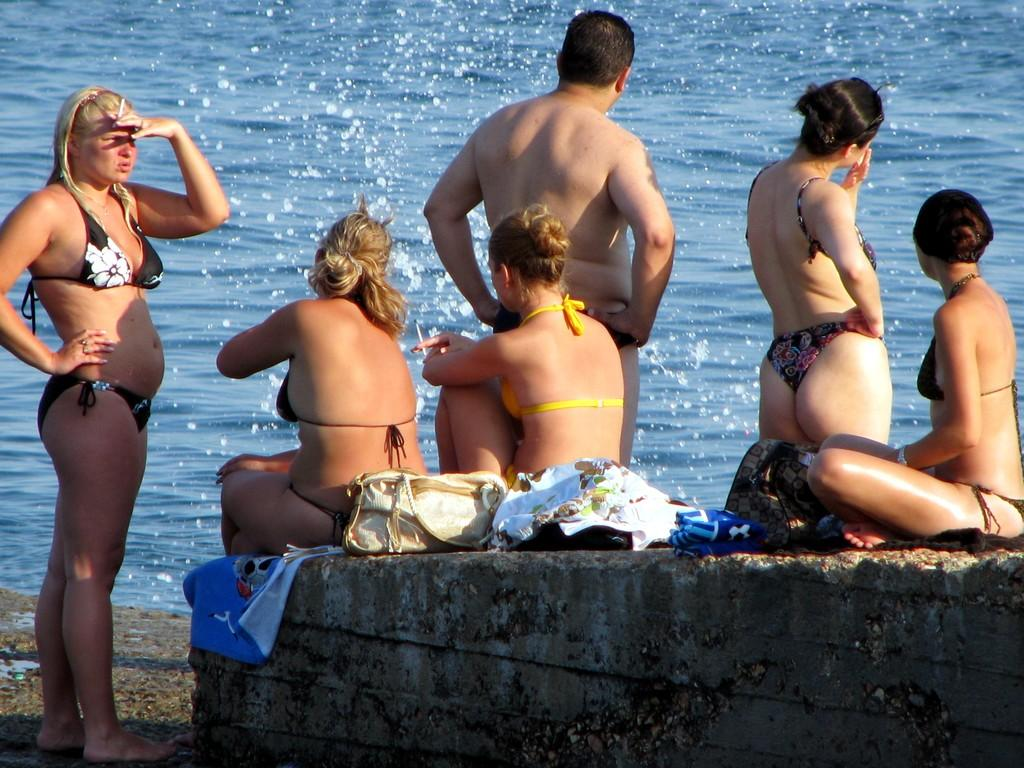How many people are present in the image? There are three people standing in the image. What are the people in the image doing? There are people standing and sitting in the image. What objects can be seen near the people? Bags and clothes are visible in the image, and they are located on a platform. What can be seen in the background of the image? Water is visible in the background of the image. Can you tell me how many owls are sitting on the clothes in the image? There are no owls present in the image; only people, bags, clothes, and water are visible. Is the lettuce being used as a prop in the image? There is no lettuce present in the image. 